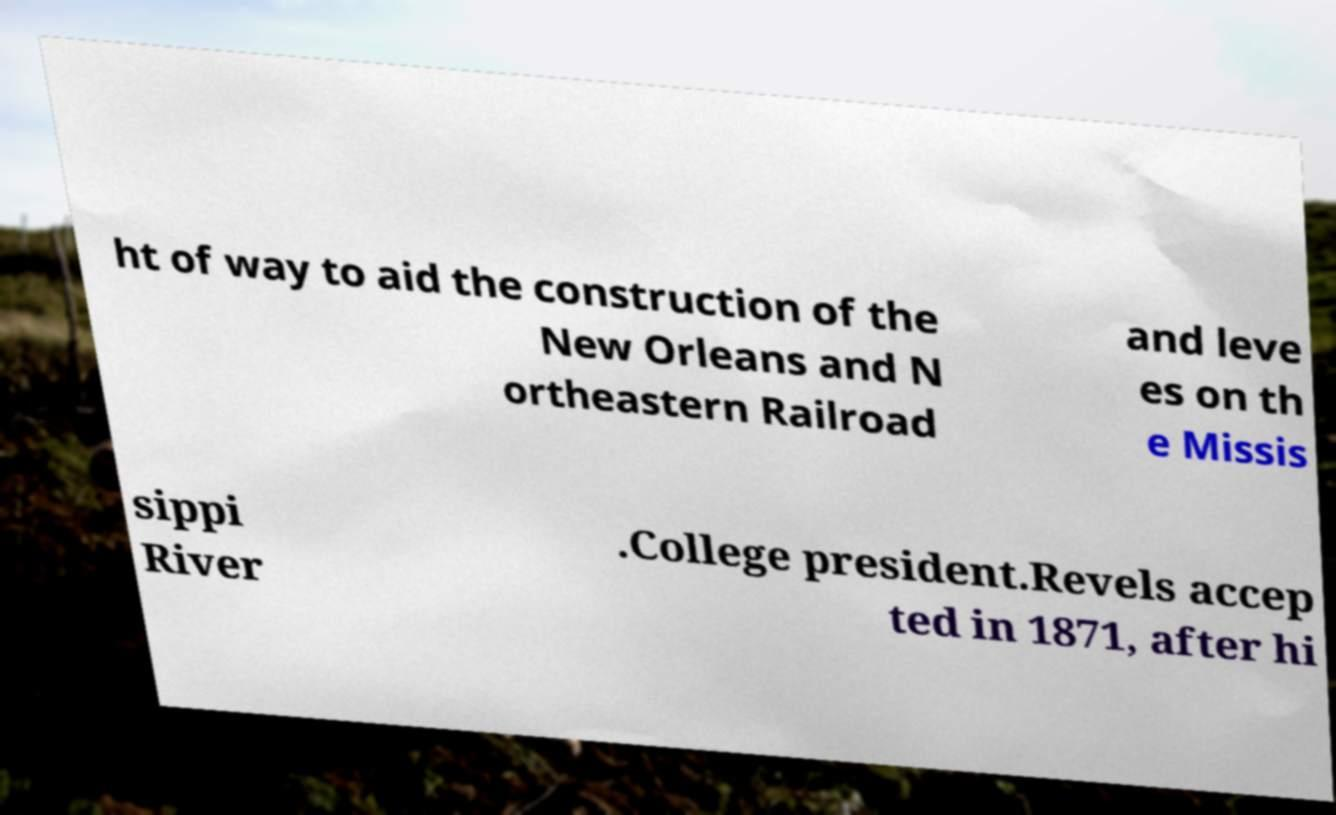What messages or text are displayed in this image? I need them in a readable, typed format. ht of way to aid the construction of the New Orleans and N ortheastern Railroad and leve es on th e Missis sippi River .College president.Revels accep ted in 1871, after hi 